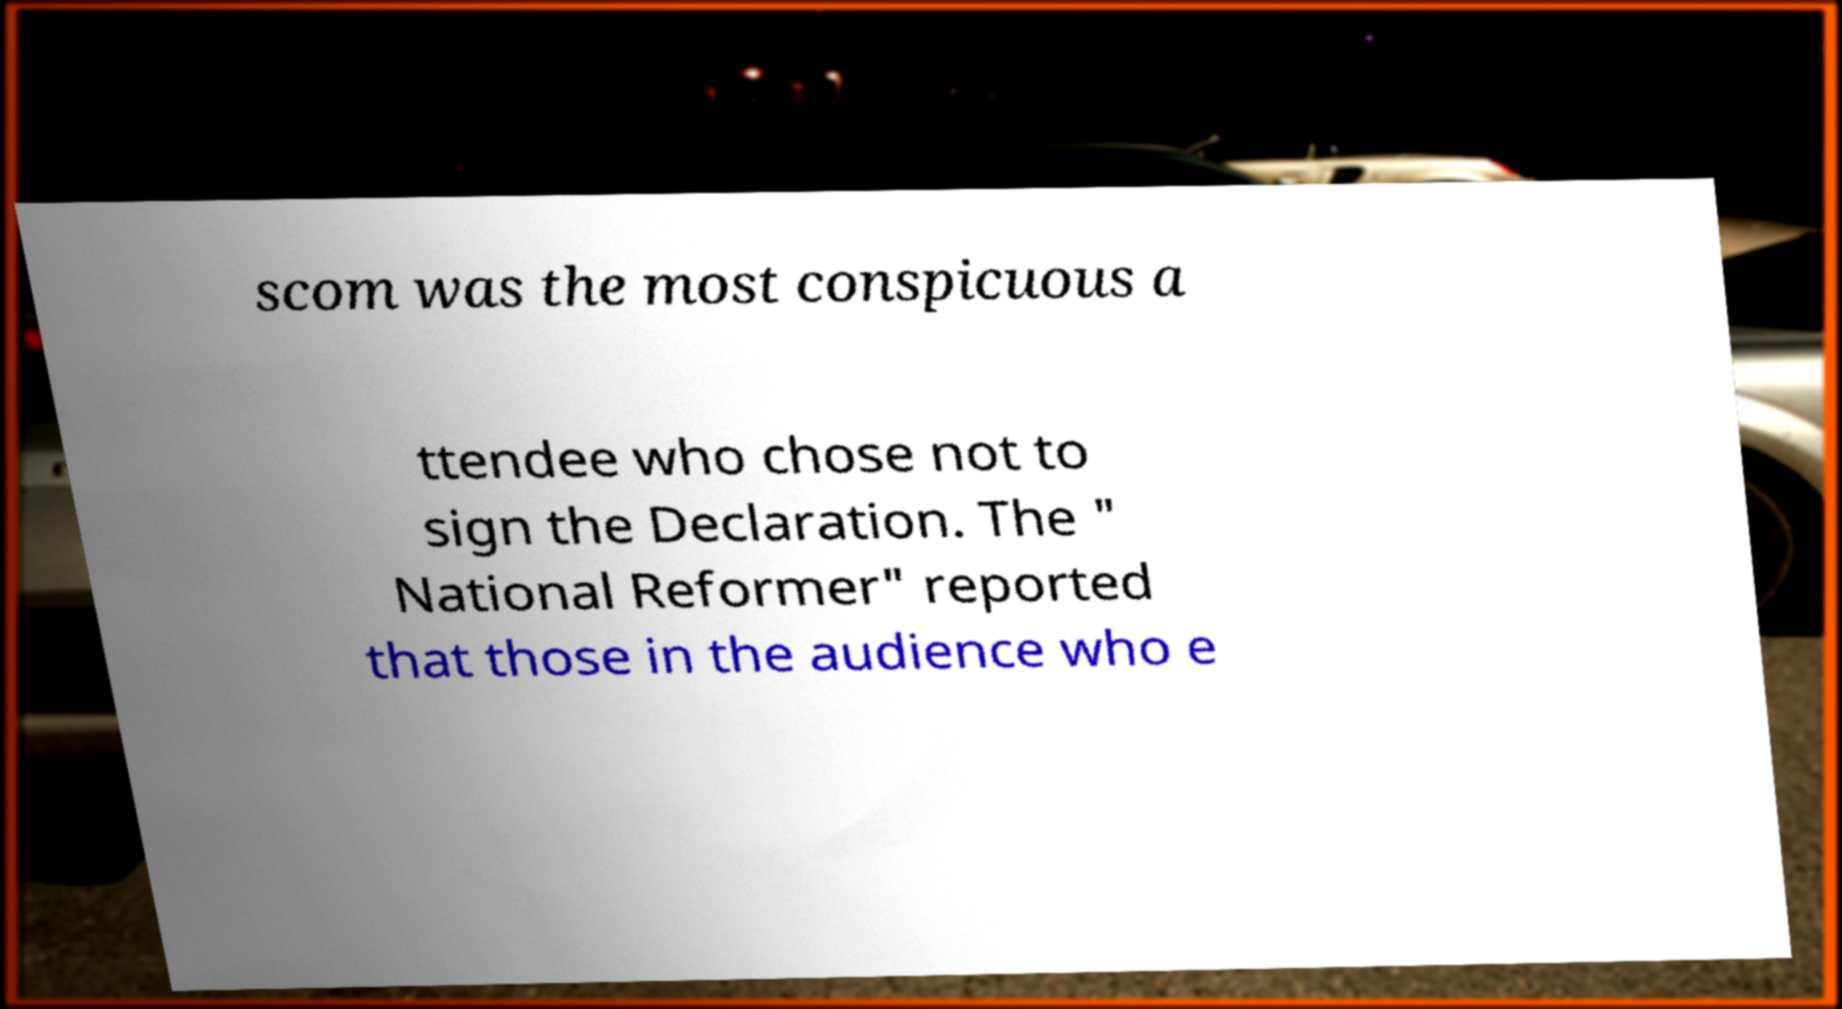Could you assist in decoding the text presented in this image and type it out clearly? scom was the most conspicuous a ttendee who chose not to sign the Declaration. The " National Reformer" reported that those in the audience who e 